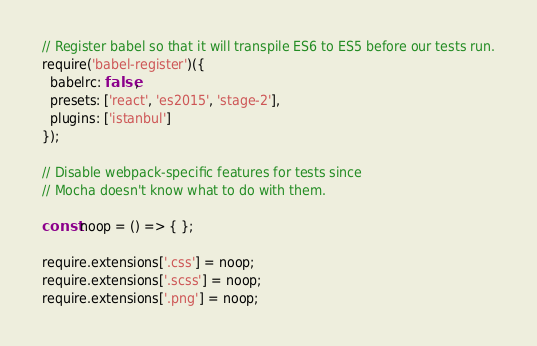Convert code to text. <code><loc_0><loc_0><loc_500><loc_500><_JavaScript_> // Register babel so that it will transpile ES6 to ES5 before our tests run. 
 require('babel-register')({
   babelrc: false,
   presets: ['react', 'es2015', 'stage-2'],
   plugins: ['istanbul']
 });
 
 // Disable webpack-specific features for tests since
 // Mocha doesn't know what to do with them.
 
 const noop = () => { };
 
 require.extensions['.css'] = noop;
 require.extensions['.scss'] = noop;
 require.extensions['.png'] = noop;</code> 